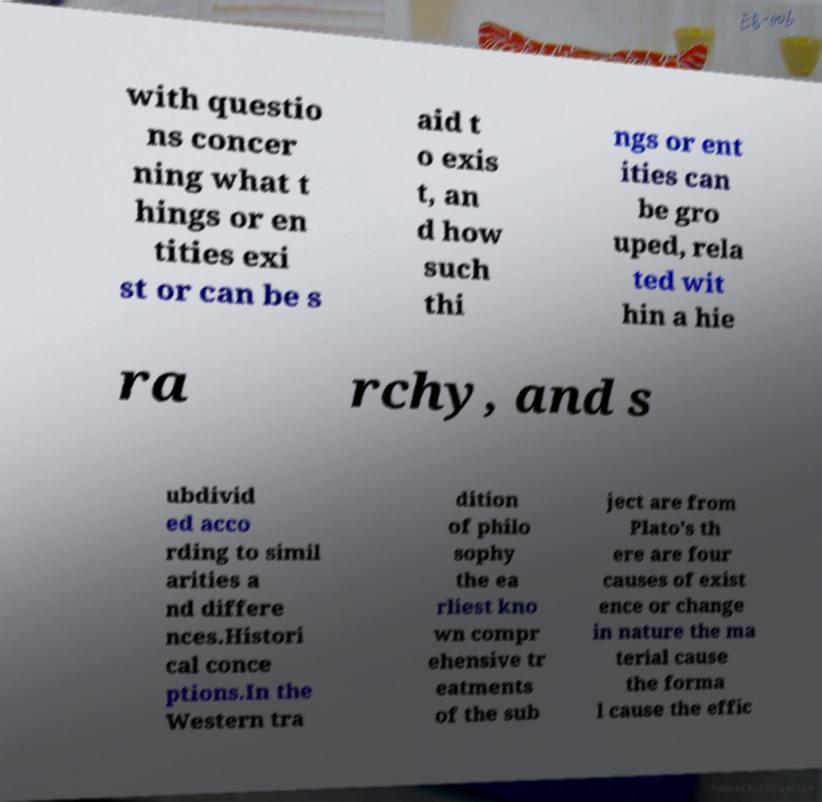Please read and relay the text visible in this image. What does it say? with questio ns concer ning what t hings or en tities exi st or can be s aid t o exis t, an d how such thi ngs or ent ities can be gro uped, rela ted wit hin a hie ra rchy, and s ubdivid ed acco rding to simil arities a nd differe nces.Histori cal conce ptions.In the Western tra dition of philo sophy the ea rliest kno wn compr ehensive tr eatments of the sub ject are from Plato's th ere are four causes of exist ence or change in nature the ma terial cause the forma l cause the effic 